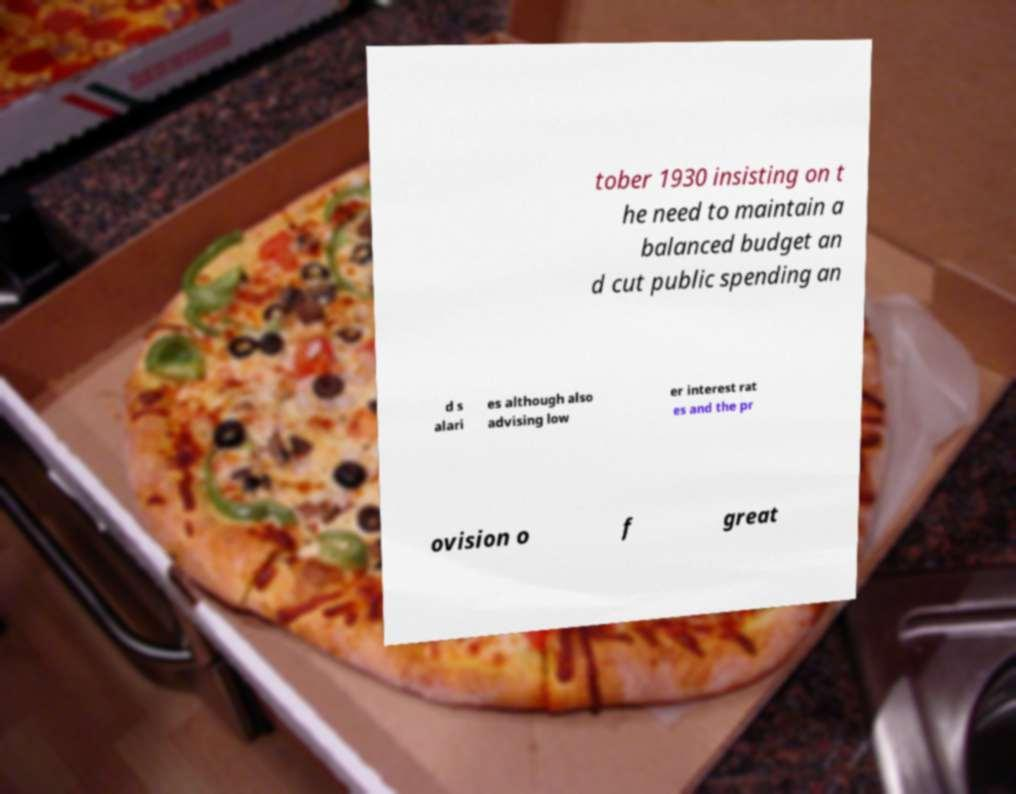What messages or text are displayed in this image? I need them in a readable, typed format. tober 1930 insisting on t he need to maintain a balanced budget an d cut public spending an d s alari es although also advising low er interest rat es and the pr ovision o f great 